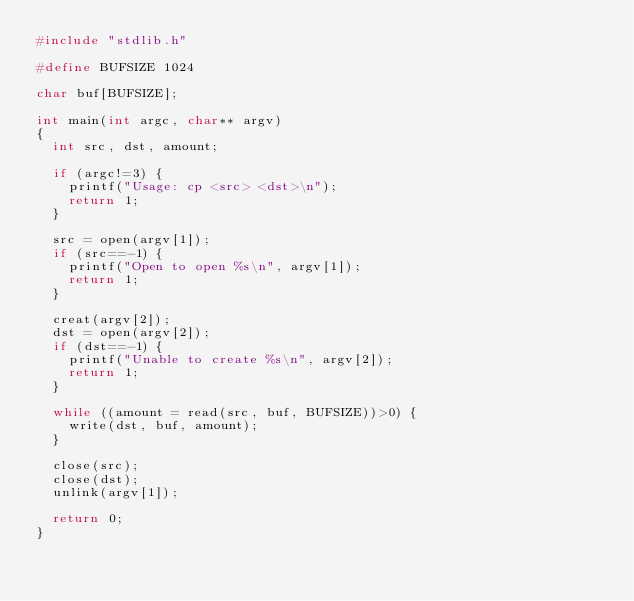<code> <loc_0><loc_0><loc_500><loc_500><_C_>#include "stdlib.h"

#define BUFSIZE 1024

char buf[BUFSIZE];

int main(int argc, char** argv)
{
  int src, dst, amount;

  if (argc!=3) {
    printf("Usage: cp <src> <dst>\n");
    return 1;
  }

  src = open(argv[1]);
  if (src==-1) {
    printf("Open to open %s\n", argv[1]);
    return 1;
  }

  creat(argv[2]);
  dst = open(argv[2]);
  if (dst==-1) {
    printf("Unable to create %s\n", argv[2]);
    return 1;
  }

  while ((amount = read(src, buf, BUFSIZE))>0) {
    write(dst, buf, amount);
  }

  close(src);
  close(dst);
  unlink(argv[1]);

  return 0;
}
</code> 